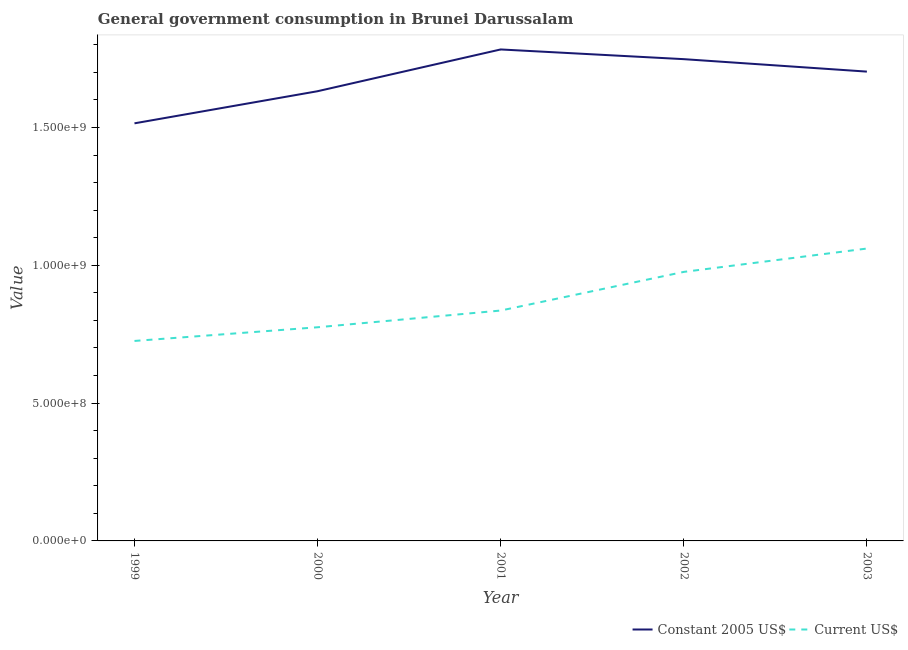How many different coloured lines are there?
Provide a succinct answer. 2. Does the line corresponding to value consumed in current us$ intersect with the line corresponding to value consumed in constant 2005 us$?
Provide a short and direct response. No. What is the value consumed in current us$ in 2002?
Keep it short and to the point. 9.76e+08. Across all years, what is the maximum value consumed in current us$?
Your answer should be compact. 1.06e+09. Across all years, what is the minimum value consumed in constant 2005 us$?
Give a very brief answer. 1.52e+09. In which year was the value consumed in constant 2005 us$ maximum?
Provide a short and direct response. 2001. In which year was the value consumed in constant 2005 us$ minimum?
Keep it short and to the point. 1999. What is the total value consumed in constant 2005 us$ in the graph?
Offer a terse response. 8.38e+09. What is the difference between the value consumed in constant 2005 us$ in 2002 and that in 2003?
Your answer should be very brief. 4.52e+07. What is the difference between the value consumed in constant 2005 us$ in 2002 and the value consumed in current us$ in 2001?
Give a very brief answer. 9.12e+08. What is the average value consumed in constant 2005 us$ per year?
Give a very brief answer. 1.68e+09. In the year 2003, what is the difference between the value consumed in constant 2005 us$ and value consumed in current us$?
Provide a succinct answer. 6.42e+08. In how many years, is the value consumed in current us$ greater than 1600000000?
Ensure brevity in your answer.  0. What is the ratio of the value consumed in current us$ in 2001 to that in 2003?
Your response must be concise. 0.79. Is the value consumed in current us$ in 1999 less than that in 2001?
Provide a succinct answer. Yes. What is the difference between the highest and the second highest value consumed in current us$?
Your answer should be compact. 8.47e+07. What is the difference between the highest and the lowest value consumed in current us$?
Your answer should be very brief. 3.35e+08. Does the value consumed in constant 2005 us$ monotonically increase over the years?
Your response must be concise. No. Is the value consumed in constant 2005 us$ strictly greater than the value consumed in current us$ over the years?
Your answer should be compact. Yes. Is the value consumed in constant 2005 us$ strictly less than the value consumed in current us$ over the years?
Your answer should be very brief. No. What is the difference between two consecutive major ticks on the Y-axis?
Make the answer very short. 5.00e+08. Does the graph contain grids?
Provide a succinct answer. No. How are the legend labels stacked?
Keep it short and to the point. Horizontal. What is the title of the graph?
Your answer should be very brief. General government consumption in Brunei Darussalam. Does "Investments" appear as one of the legend labels in the graph?
Offer a terse response. No. What is the label or title of the X-axis?
Your answer should be very brief. Year. What is the label or title of the Y-axis?
Provide a short and direct response. Value. What is the Value in Constant 2005 US$ in 1999?
Your answer should be very brief. 1.52e+09. What is the Value in Current US$ in 1999?
Provide a short and direct response. 7.26e+08. What is the Value in Constant 2005 US$ in 2000?
Make the answer very short. 1.63e+09. What is the Value of Current US$ in 2000?
Your response must be concise. 7.75e+08. What is the Value in Constant 2005 US$ in 2001?
Make the answer very short. 1.78e+09. What is the Value in Current US$ in 2001?
Make the answer very short. 8.36e+08. What is the Value in Constant 2005 US$ in 2002?
Provide a succinct answer. 1.75e+09. What is the Value of Current US$ in 2002?
Offer a terse response. 9.76e+08. What is the Value in Constant 2005 US$ in 2003?
Keep it short and to the point. 1.70e+09. What is the Value of Current US$ in 2003?
Your answer should be compact. 1.06e+09. Across all years, what is the maximum Value of Constant 2005 US$?
Provide a succinct answer. 1.78e+09. Across all years, what is the maximum Value in Current US$?
Your answer should be very brief. 1.06e+09. Across all years, what is the minimum Value of Constant 2005 US$?
Give a very brief answer. 1.52e+09. Across all years, what is the minimum Value in Current US$?
Offer a terse response. 7.26e+08. What is the total Value in Constant 2005 US$ in the graph?
Your response must be concise. 8.38e+09. What is the total Value of Current US$ in the graph?
Offer a very short reply. 4.37e+09. What is the difference between the Value in Constant 2005 US$ in 1999 and that in 2000?
Your answer should be very brief. -1.17e+08. What is the difference between the Value in Current US$ in 1999 and that in 2000?
Keep it short and to the point. -4.96e+07. What is the difference between the Value of Constant 2005 US$ in 1999 and that in 2001?
Ensure brevity in your answer.  -2.68e+08. What is the difference between the Value of Current US$ in 1999 and that in 2001?
Provide a short and direct response. -1.10e+08. What is the difference between the Value in Constant 2005 US$ in 1999 and that in 2002?
Make the answer very short. -2.33e+08. What is the difference between the Value in Current US$ in 1999 and that in 2002?
Provide a short and direct response. -2.51e+08. What is the difference between the Value of Constant 2005 US$ in 1999 and that in 2003?
Your answer should be compact. -1.88e+08. What is the difference between the Value of Current US$ in 1999 and that in 2003?
Your answer should be compact. -3.35e+08. What is the difference between the Value of Constant 2005 US$ in 2000 and that in 2001?
Your answer should be compact. -1.52e+08. What is the difference between the Value in Current US$ in 2000 and that in 2001?
Offer a very short reply. -6.07e+07. What is the difference between the Value in Constant 2005 US$ in 2000 and that in 2002?
Make the answer very short. -1.16e+08. What is the difference between the Value of Current US$ in 2000 and that in 2002?
Offer a terse response. -2.01e+08. What is the difference between the Value of Constant 2005 US$ in 2000 and that in 2003?
Make the answer very short. -7.11e+07. What is the difference between the Value in Current US$ in 2000 and that in 2003?
Your answer should be compact. -2.86e+08. What is the difference between the Value in Constant 2005 US$ in 2001 and that in 2002?
Offer a terse response. 3.52e+07. What is the difference between the Value in Current US$ in 2001 and that in 2002?
Provide a succinct answer. -1.40e+08. What is the difference between the Value of Constant 2005 US$ in 2001 and that in 2003?
Provide a succinct answer. 8.04e+07. What is the difference between the Value of Current US$ in 2001 and that in 2003?
Your answer should be very brief. -2.25e+08. What is the difference between the Value in Constant 2005 US$ in 2002 and that in 2003?
Provide a short and direct response. 4.52e+07. What is the difference between the Value in Current US$ in 2002 and that in 2003?
Keep it short and to the point. -8.47e+07. What is the difference between the Value in Constant 2005 US$ in 1999 and the Value in Current US$ in 2000?
Provide a short and direct response. 7.40e+08. What is the difference between the Value of Constant 2005 US$ in 1999 and the Value of Current US$ in 2001?
Your answer should be compact. 6.79e+08. What is the difference between the Value in Constant 2005 US$ in 1999 and the Value in Current US$ in 2002?
Provide a short and direct response. 5.39e+08. What is the difference between the Value in Constant 2005 US$ in 1999 and the Value in Current US$ in 2003?
Offer a very short reply. 4.54e+08. What is the difference between the Value in Constant 2005 US$ in 2000 and the Value in Current US$ in 2001?
Provide a short and direct response. 7.96e+08. What is the difference between the Value of Constant 2005 US$ in 2000 and the Value of Current US$ in 2002?
Your answer should be compact. 6.55e+08. What is the difference between the Value in Constant 2005 US$ in 2000 and the Value in Current US$ in 2003?
Give a very brief answer. 5.71e+08. What is the difference between the Value in Constant 2005 US$ in 2001 and the Value in Current US$ in 2002?
Provide a short and direct response. 8.07e+08. What is the difference between the Value in Constant 2005 US$ in 2001 and the Value in Current US$ in 2003?
Your answer should be very brief. 7.22e+08. What is the difference between the Value of Constant 2005 US$ in 2002 and the Value of Current US$ in 2003?
Offer a terse response. 6.87e+08. What is the average Value of Constant 2005 US$ per year?
Your answer should be compact. 1.68e+09. What is the average Value of Current US$ per year?
Offer a very short reply. 8.75e+08. In the year 1999, what is the difference between the Value in Constant 2005 US$ and Value in Current US$?
Give a very brief answer. 7.89e+08. In the year 2000, what is the difference between the Value in Constant 2005 US$ and Value in Current US$?
Make the answer very short. 8.56e+08. In the year 2001, what is the difference between the Value in Constant 2005 US$ and Value in Current US$?
Provide a short and direct response. 9.47e+08. In the year 2002, what is the difference between the Value in Constant 2005 US$ and Value in Current US$?
Your answer should be very brief. 7.72e+08. In the year 2003, what is the difference between the Value in Constant 2005 US$ and Value in Current US$?
Your answer should be very brief. 6.42e+08. What is the ratio of the Value of Current US$ in 1999 to that in 2000?
Offer a terse response. 0.94. What is the ratio of the Value in Constant 2005 US$ in 1999 to that in 2001?
Make the answer very short. 0.85. What is the ratio of the Value of Current US$ in 1999 to that in 2001?
Keep it short and to the point. 0.87. What is the ratio of the Value in Constant 2005 US$ in 1999 to that in 2002?
Provide a succinct answer. 0.87. What is the ratio of the Value of Current US$ in 1999 to that in 2002?
Provide a short and direct response. 0.74. What is the ratio of the Value in Constant 2005 US$ in 1999 to that in 2003?
Your answer should be very brief. 0.89. What is the ratio of the Value of Current US$ in 1999 to that in 2003?
Offer a very short reply. 0.68. What is the ratio of the Value of Constant 2005 US$ in 2000 to that in 2001?
Offer a very short reply. 0.92. What is the ratio of the Value in Current US$ in 2000 to that in 2001?
Your response must be concise. 0.93. What is the ratio of the Value of Constant 2005 US$ in 2000 to that in 2002?
Your answer should be very brief. 0.93. What is the ratio of the Value of Current US$ in 2000 to that in 2002?
Provide a short and direct response. 0.79. What is the ratio of the Value of Constant 2005 US$ in 2000 to that in 2003?
Offer a very short reply. 0.96. What is the ratio of the Value in Current US$ in 2000 to that in 2003?
Provide a short and direct response. 0.73. What is the ratio of the Value of Constant 2005 US$ in 2001 to that in 2002?
Ensure brevity in your answer.  1.02. What is the ratio of the Value in Current US$ in 2001 to that in 2002?
Offer a terse response. 0.86. What is the ratio of the Value in Constant 2005 US$ in 2001 to that in 2003?
Offer a very short reply. 1.05. What is the ratio of the Value of Current US$ in 2001 to that in 2003?
Give a very brief answer. 0.79. What is the ratio of the Value of Constant 2005 US$ in 2002 to that in 2003?
Your answer should be compact. 1.03. What is the ratio of the Value of Current US$ in 2002 to that in 2003?
Your response must be concise. 0.92. What is the difference between the highest and the second highest Value in Constant 2005 US$?
Your answer should be compact. 3.52e+07. What is the difference between the highest and the second highest Value in Current US$?
Make the answer very short. 8.47e+07. What is the difference between the highest and the lowest Value in Constant 2005 US$?
Provide a short and direct response. 2.68e+08. What is the difference between the highest and the lowest Value of Current US$?
Your answer should be compact. 3.35e+08. 